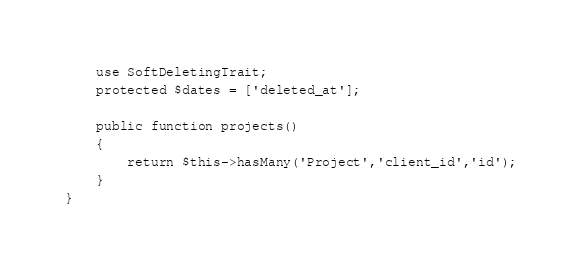Convert code to text. <code><loc_0><loc_0><loc_500><loc_500><_PHP_>	use SoftDeletingTrait;
	protected $dates = ['deleted_at'];

	public function projects()
    {
        return $this->hasMany('Project','client_id','id');
    }
}</code> 